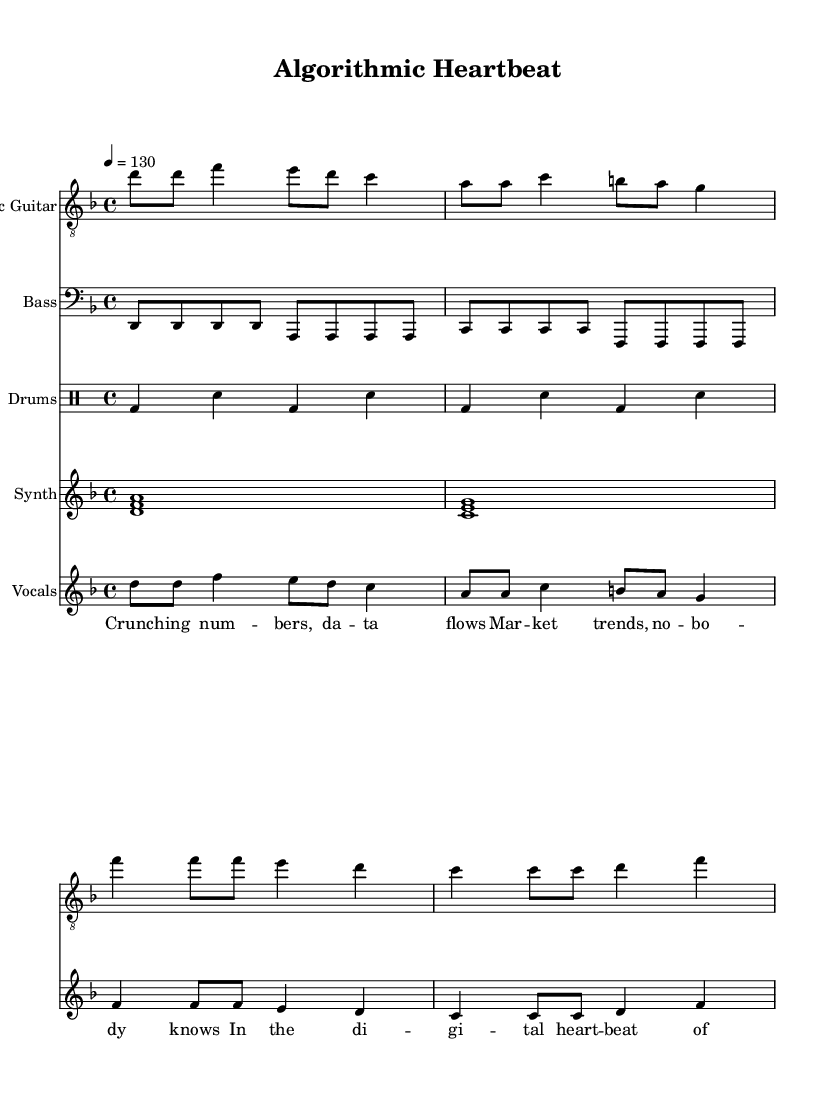What is the key signature of this music? The key signature is indicated by the sharp or flat symbols on the staff. In this case, there are no sharps or flats, which indicates the key is D minor (one flat).
Answer: D minor What is the time signature of this music? The time signature is shown at the beginning of the staff, represented as 4/4, meaning there are four beats in each measure and the quarter note gets one beat.
Answer: 4/4 What is the tempo marking of the piece? The tempo is indicated at the beginning with a note value and a number; here it is written as "4 = 130", meaning the quarter note gets 130 beats per minute.
Answer: 130 How many measures are in the electric guitar part? By counting the measures in the electric guitar staff, there are a total of 8 measures present in this part of the music.
Answer: 8 What type of rhythm does the drums part primarily use? The drums part alternates between bass drum and snare drum, utilizing a simple back-and-forth rhythm commonly found in rock music.
Answer: Bass and snare What lyrical theme is represented in the verse words? The verse lyrics talk about "crunching numbers" and "data flows," indicating themes of analytics and finance, which ties into the overarching concept of investment strategies and trading.
Answer: Data and finance How does the chorus relate to the verse in terms of message? The chorus emphasizes "digital heartbeat of trade" and "riding waves," which expands on the verse's focus by highlighting action and participation in market trends, portraying a sense of engagement with the trading environment.
Answer: Engagement with trade 